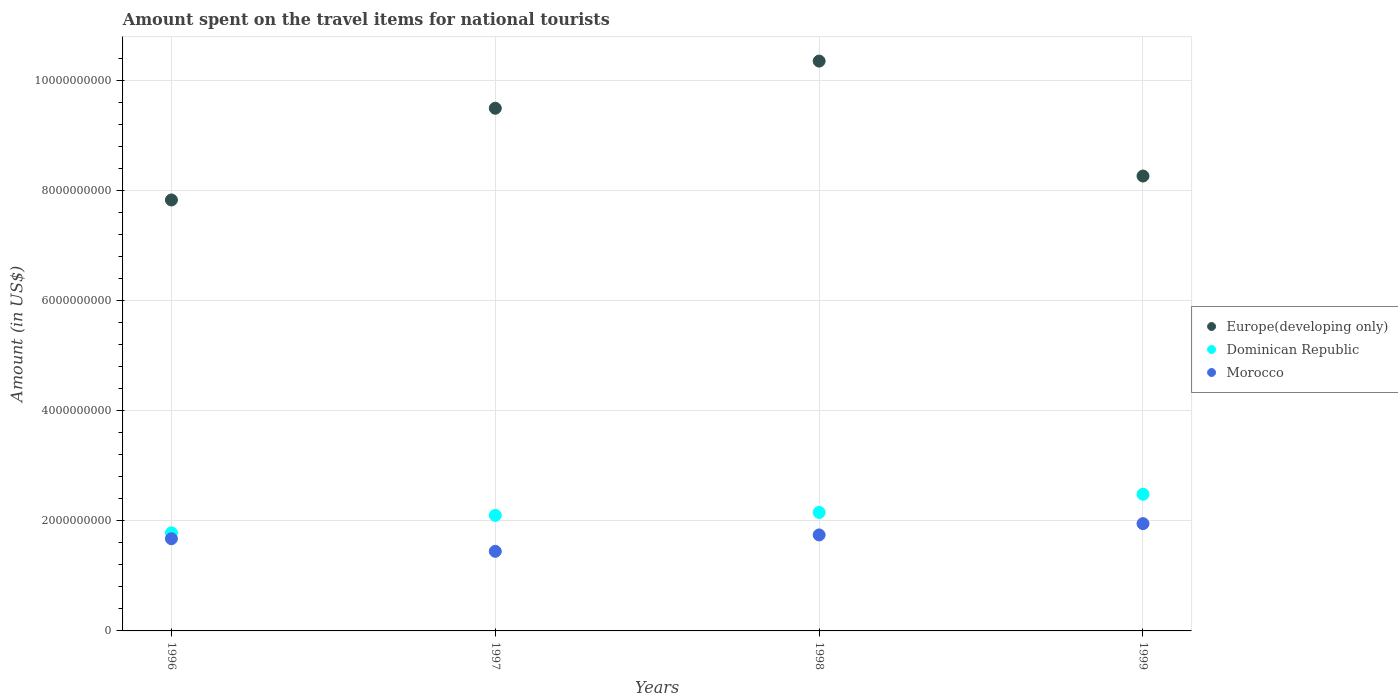Is the number of dotlines equal to the number of legend labels?
Your response must be concise. Yes. What is the amount spent on the travel items for national tourists in Europe(developing only) in 1998?
Give a very brief answer. 1.04e+1. Across all years, what is the maximum amount spent on the travel items for national tourists in Europe(developing only)?
Your response must be concise. 1.04e+1. Across all years, what is the minimum amount spent on the travel items for national tourists in Morocco?
Keep it short and to the point. 1.45e+09. In which year was the amount spent on the travel items for national tourists in Morocco minimum?
Give a very brief answer. 1997. What is the total amount spent on the travel items for national tourists in Dominican Republic in the graph?
Offer a very short reply. 8.52e+09. What is the difference between the amount spent on the travel items for national tourists in Dominican Republic in 1998 and that in 1999?
Your response must be concise. -3.30e+08. What is the difference between the amount spent on the travel items for national tourists in Europe(developing only) in 1997 and the amount spent on the travel items for national tourists in Morocco in 1999?
Offer a very short reply. 7.55e+09. What is the average amount spent on the travel items for national tourists in Dominican Republic per year?
Provide a short and direct response. 2.13e+09. In the year 1998, what is the difference between the amount spent on the travel items for national tourists in Dominican Republic and amount spent on the travel items for national tourists in Morocco?
Provide a short and direct response. 4.09e+08. What is the ratio of the amount spent on the travel items for national tourists in Dominican Republic in 1996 to that in 1997?
Ensure brevity in your answer.  0.85. Is the amount spent on the travel items for national tourists in Morocco in 1996 less than that in 1999?
Your response must be concise. Yes. Is the difference between the amount spent on the travel items for national tourists in Dominican Republic in 1996 and 1998 greater than the difference between the amount spent on the travel items for national tourists in Morocco in 1996 and 1998?
Offer a very short reply. No. What is the difference between the highest and the second highest amount spent on the travel items for national tourists in Dominican Republic?
Provide a short and direct response. 3.30e+08. What is the difference between the highest and the lowest amount spent on the travel items for national tourists in Dominican Republic?
Your answer should be very brief. 7.02e+08. How many dotlines are there?
Give a very brief answer. 3. How many years are there in the graph?
Offer a very short reply. 4. What is the difference between two consecutive major ticks on the Y-axis?
Make the answer very short. 2.00e+09. Are the values on the major ticks of Y-axis written in scientific E-notation?
Offer a very short reply. No. Does the graph contain grids?
Give a very brief answer. Yes. How many legend labels are there?
Your response must be concise. 3. What is the title of the graph?
Your answer should be very brief. Amount spent on the travel items for national tourists. Does "Albania" appear as one of the legend labels in the graph?
Offer a terse response. No. What is the label or title of the Y-axis?
Make the answer very short. Amount (in US$). What is the Amount (in US$) in Europe(developing only) in 1996?
Provide a succinct answer. 7.83e+09. What is the Amount (in US$) in Dominican Republic in 1996?
Your answer should be compact. 1.78e+09. What is the Amount (in US$) in Morocco in 1996?
Your answer should be compact. 1.68e+09. What is the Amount (in US$) of Europe(developing only) in 1997?
Give a very brief answer. 9.50e+09. What is the Amount (in US$) of Dominican Republic in 1997?
Give a very brief answer. 2.10e+09. What is the Amount (in US$) of Morocco in 1997?
Keep it short and to the point. 1.45e+09. What is the Amount (in US$) in Europe(developing only) in 1998?
Ensure brevity in your answer.  1.04e+1. What is the Amount (in US$) in Dominican Republic in 1998?
Ensure brevity in your answer.  2.15e+09. What is the Amount (in US$) of Morocco in 1998?
Give a very brief answer. 1.74e+09. What is the Amount (in US$) of Europe(developing only) in 1999?
Offer a very short reply. 8.26e+09. What is the Amount (in US$) of Dominican Republic in 1999?
Offer a very short reply. 2.48e+09. What is the Amount (in US$) of Morocco in 1999?
Offer a terse response. 1.95e+09. Across all years, what is the maximum Amount (in US$) in Europe(developing only)?
Provide a short and direct response. 1.04e+1. Across all years, what is the maximum Amount (in US$) of Dominican Republic?
Give a very brief answer. 2.48e+09. Across all years, what is the maximum Amount (in US$) in Morocco?
Offer a very short reply. 1.95e+09. Across all years, what is the minimum Amount (in US$) of Europe(developing only)?
Ensure brevity in your answer.  7.83e+09. Across all years, what is the minimum Amount (in US$) in Dominican Republic?
Offer a terse response. 1.78e+09. Across all years, what is the minimum Amount (in US$) of Morocco?
Provide a succinct answer. 1.45e+09. What is the total Amount (in US$) of Europe(developing only) in the graph?
Keep it short and to the point. 3.59e+1. What is the total Amount (in US$) in Dominican Republic in the graph?
Offer a very short reply. 8.52e+09. What is the total Amount (in US$) of Morocco in the graph?
Provide a succinct answer. 6.81e+09. What is the difference between the Amount (in US$) in Europe(developing only) in 1996 and that in 1997?
Provide a short and direct response. -1.67e+09. What is the difference between the Amount (in US$) in Dominican Republic in 1996 and that in 1997?
Give a very brief answer. -3.18e+08. What is the difference between the Amount (in US$) in Morocco in 1996 and that in 1997?
Provide a short and direct response. 2.29e+08. What is the difference between the Amount (in US$) in Europe(developing only) in 1996 and that in 1998?
Offer a terse response. -2.52e+09. What is the difference between the Amount (in US$) of Dominican Republic in 1996 and that in 1998?
Offer a terse response. -3.72e+08. What is the difference between the Amount (in US$) of Morocco in 1996 and that in 1998?
Keep it short and to the point. -6.90e+07. What is the difference between the Amount (in US$) of Europe(developing only) in 1996 and that in 1999?
Give a very brief answer. -4.35e+08. What is the difference between the Amount (in US$) in Dominican Republic in 1996 and that in 1999?
Your answer should be compact. -7.02e+08. What is the difference between the Amount (in US$) of Morocco in 1996 and that in 1999?
Provide a succinct answer. -2.74e+08. What is the difference between the Amount (in US$) of Europe(developing only) in 1997 and that in 1998?
Give a very brief answer. -8.57e+08. What is the difference between the Amount (in US$) in Dominican Republic in 1997 and that in 1998?
Provide a succinct answer. -5.40e+07. What is the difference between the Amount (in US$) of Morocco in 1997 and that in 1998?
Your answer should be very brief. -2.98e+08. What is the difference between the Amount (in US$) in Europe(developing only) in 1997 and that in 1999?
Make the answer very short. 1.23e+09. What is the difference between the Amount (in US$) of Dominican Republic in 1997 and that in 1999?
Make the answer very short. -3.84e+08. What is the difference between the Amount (in US$) in Morocco in 1997 and that in 1999?
Make the answer very short. -5.03e+08. What is the difference between the Amount (in US$) in Europe(developing only) in 1998 and that in 1999?
Ensure brevity in your answer.  2.09e+09. What is the difference between the Amount (in US$) of Dominican Republic in 1998 and that in 1999?
Ensure brevity in your answer.  -3.30e+08. What is the difference between the Amount (in US$) of Morocco in 1998 and that in 1999?
Make the answer very short. -2.05e+08. What is the difference between the Amount (in US$) of Europe(developing only) in 1996 and the Amount (in US$) of Dominican Republic in 1997?
Offer a very short reply. 5.73e+09. What is the difference between the Amount (in US$) in Europe(developing only) in 1996 and the Amount (in US$) in Morocco in 1997?
Offer a terse response. 6.38e+09. What is the difference between the Amount (in US$) in Dominican Republic in 1996 and the Amount (in US$) in Morocco in 1997?
Make the answer very short. 3.35e+08. What is the difference between the Amount (in US$) of Europe(developing only) in 1996 and the Amount (in US$) of Dominican Republic in 1998?
Make the answer very short. 5.68e+09. What is the difference between the Amount (in US$) of Europe(developing only) in 1996 and the Amount (in US$) of Morocco in 1998?
Your answer should be compact. 6.09e+09. What is the difference between the Amount (in US$) in Dominican Republic in 1996 and the Amount (in US$) in Morocco in 1998?
Ensure brevity in your answer.  3.70e+07. What is the difference between the Amount (in US$) of Europe(developing only) in 1996 and the Amount (in US$) of Dominican Republic in 1999?
Make the answer very short. 5.35e+09. What is the difference between the Amount (in US$) in Europe(developing only) in 1996 and the Amount (in US$) in Morocco in 1999?
Give a very brief answer. 5.88e+09. What is the difference between the Amount (in US$) in Dominican Republic in 1996 and the Amount (in US$) in Morocco in 1999?
Your response must be concise. -1.68e+08. What is the difference between the Amount (in US$) in Europe(developing only) in 1997 and the Amount (in US$) in Dominican Republic in 1998?
Provide a succinct answer. 7.34e+09. What is the difference between the Amount (in US$) in Europe(developing only) in 1997 and the Amount (in US$) in Morocco in 1998?
Ensure brevity in your answer.  7.75e+09. What is the difference between the Amount (in US$) in Dominican Republic in 1997 and the Amount (in US$) in Morocco in 1998?
Make the answer very short. 3.55e+08. What is the difference between the Amount (in US$) of Europe(developing only) in 1997 and the Amount (in US$) of Dominican Republic in 1999?
Your response must be concise. 7.01e+09. What is the difference between the Amount (in US$) of Europe(developing only) in 1997 and the Amount (in US$) of Morocco in 1999?
Keep it short and to the point. 7.55e+09. What is the difference between the Amount (in US$) in Dominican Republic in 1997 and the Amount (in US$) in Morocco in 1999?
Offer a terse response. 1.50e+08. What is the difference between the Amount (in US$) in Europe(developing only) in 1998 and the Amount (in US$) in Dominican Republic in 1999?
Ensure brevity in your answer.  7.87e+09. What is the difference between the Amount (in US$) of Europe(developing only) in 1998 and the Amount (in US$) of Morocco in 1999?
Ensure brevity in your answer.  8.40e+09. What is the difference between the Amount (in US$) of Dominican Republic in 1998 and the Amount (in US$) of Morocco in 1999?
Give a very brief answer. 2.04e+08. What is the average Amount (in US$) of Europe(developing only) per year?
Offer a very short reply. 8.99e+09. What is the average Amount (in US$) of Dominican Republic per year?
Provide a short and direct response. 2.13e+09. What is the average Amount (in US$) of Morocco per year?
Ensure brevity in your answer.  1.70e+09. In the year 1996, what is the difference between the Amount (in US$) of Europe(developing only) and Amount (in US$) of Dominican Republic?
Provide a short and direct response. 6.05e+09. In the year 1996, what is the difference between the Amount (in US$) of Europe(developing only) and Amount (in US$) of Morocco?
Your answer should be compact. 6.15e+09. In the year 1996, what is the difference between the Amount (in US$) of Dominican Republic and Amount (in US$) of Morocco?
Ensure brevity in your answer.  1.06e+08. In the year 1997, what is the difference between the Amount (in US$) of Europe(developing only) and Amount (in US$) of Dominican Republic?
Offer a very short reply. 7.40e+09. In the year 1997, what is the difference between the Amount (in US$) of Europe(developing only) and Amount (in US$) of Morocco?
Provide a short and direct response. 8.05e+09. In the year 1997, what is the difference between the Amount (in US$) of Dominican Republic and Amount (in US$) of Morocco?
Give a very brief answer. 6.53e+08. In the year 1998, what is the difference between the Amount (in US$) in Europe(developing only) and Amount (in US$) in Dominican Republic?
Provide a succinct answer. 8.20e+09. In the year 1998, what is the difference between the Amount (in US$) of Europe(developing only) and Amount (in US$) of Morocco?
Your response must be concise. 8.61e+09. In the year 1998, what is the difference between the Amount (in US$) of Dominican Republic and Amount (in US$) of Morocco?
Your answer should be very brief. 4.09e+08. In the year 1999, what is the difference between the Amount (in US$) of Europe(developing only) and Amount (in US$) of Dominican Republic?
Provide a succinct answer. 5.78e+09. In the year 1999, what is the difference between the Amount (in US$) in Europe(developing only) and Amount (in US$) in Morocco?
Make the answer very short. 6.32e+09. In the year 1999, what is the difference between the Amount (in US$) of Dominican Republic and Amount (in US$) of Morocco?
Your answer should be very brief. 5.34e+08. What is the ratio of the Amount (in US$) of Europe(developing only) in 1996 to that in 1997?
Your response must be concise. 0.82. What is the ratio of the Amount (in US$) of Dominican Republic in 1996 to that in 1997?
Offer a terse response. 0.85. What is the ratio of the Amount (in US$) of Morocco in 1996 to that in 1997?
Provide a short and direct response. 1.16. What is the ratio of the Amount (in US$) in Europe(developing only) in 1996 to that in 1998?
Offer a terse response. 0.76. What is the ratio of the Amount (in US$) in Dominican Republic in 1996 to that in 1998?
Your answer should be compact. 0.83. What is the ratio of the Amount (in US$) of Morocco in 1996 to that in 1998?
Offer a terse response. 0.96. What is the ratio of the Amount (in US$) in Dominican Republic in 1996 to that in 1999?
Keep it short and to the point. 0.72. What is the ratio of the Amount (in US$) in Morocco in 1996 to that in 1999?
Provide a succinct answer. 0.86. What is the ratio of the Amount (in US$) of Europe(developing only) in 1997 to that in 1998?
Keep it short and to the point. 0.92. What is the ratio of the Amount (in US$) in Dominican Republic in 1997 to that in 1998?
Provide a short and direct response. 0.97. What is the ratio of the Amount (in US$) of Morocco in 1997 to that in 1998?
Keep it short and to the point. 0.83. What is the ratio of the Amount (in US$) in Europe(developing only) in 1997 to that in 1999?
Make the answer very short. 1.15. What is the ratio of the Amount (in US$) in Dominican Republic in 1997 to that in 1999?
Your answer should be very brief. 0.85. What is the ratio of the Amount (in US$) in Morocco in 1997 to that in 1999?
Ensure brevity in your answer.  0.74. What is the ratio of the Amount (in US$) of Europe(developing only) in 1998 to that in 1999?
Your response must be concise. 1.25. What is the ratio of the Amount (in US$) in Dominican Republic in 1998 to that in 1999?
Offer a terse response. 0.87. What is the ratio of the Amount (in US$) of Morocco in 1998 to that in 1999?
Offer a terse response. 0.89. What is the difference between the highest and the second highest Amount (in US$) in Europe(developing only)?
Provide a succinct answer. 8.57e+08. What is the difference between the highest and the second highest Amount (in US$) in Dominican Republic?
Give a very brief answer. 3.30e+08. What is the difference between the highest and the second highest Amount (in US$) in Morocco?
Your answer should be compact. 2.05e+08. What is the difference between the highest and the lowest Amount (in US$) in Europe(developing only)?
Make the answer very short. 2.52e+09. What is the difference between the highest and the lowest Amount (in US$) in Dominican Republic?
Your answer should be compact. 7.02e+08. What is the difference between the highest and the lowest Amount (in US$) in Morocco?
Your answer should be compact. 5.03e+08. 